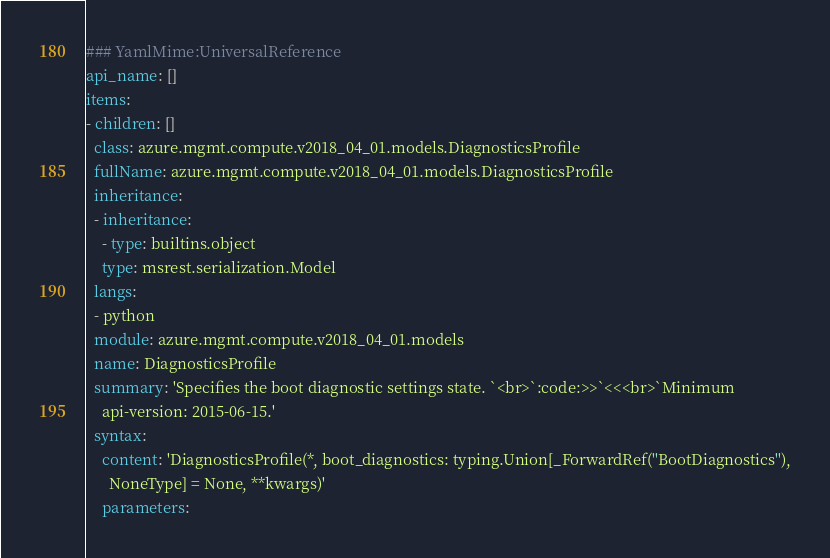Convert code to text. <code><loc_0><loc_0><loc_500><loc_500><_YAML_>### YamlMime:UniversalReference
api_name: []
items:
- children: []
  class: azure.mgmt.compute.v2018_04_01.models.DiagnosticsProfile
  fullName: azure.mgmt.compute.v2018_04_01.models.DiagnosticsProfile
  inheritance:
  - inheritance:
    - type: builtins.object
    type: msrest.serialization.Model
  langs:
  - python
  module: azure.mgmt.compute.v2018_04_01.models
  name: DiagnosticsProfile
  summary: 'Specifies the boot diagnostic settings state. `<br>`:code:>>`<<<br>`Minimum
    api-version: 2015-06-15.'
  syntax:
    content: 'DiagnosticsProfile(*, boot_diagnostics: typing.Union[_ForwardRef(''BootDiagnostics''),
      NoneType] = None, **kwargs)'
    parameters:</code> 